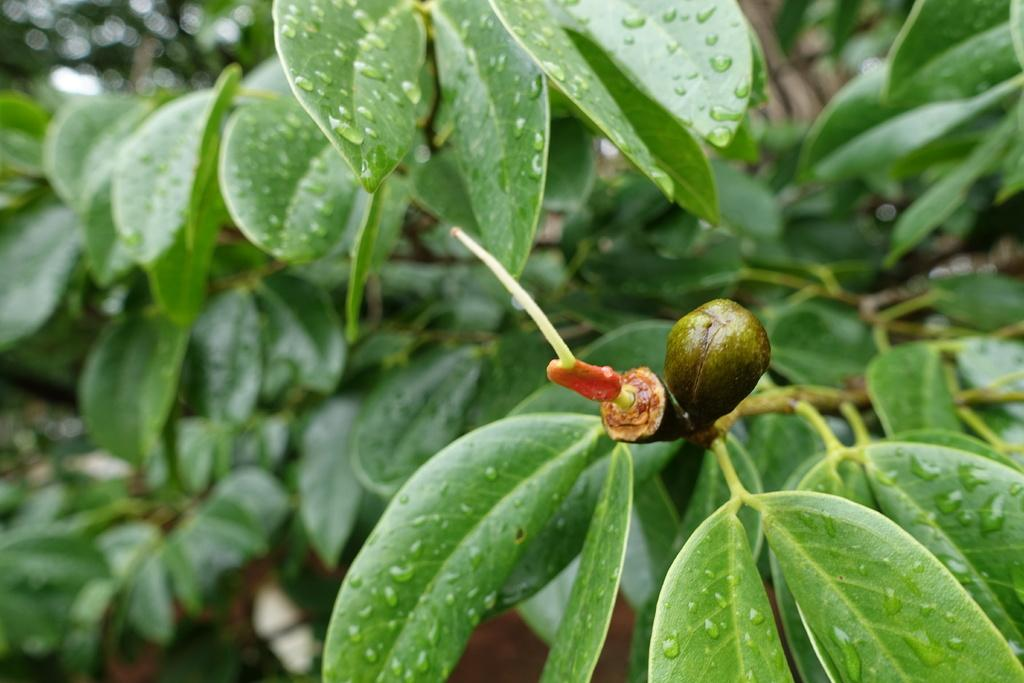What type of vegetation is present in the image? There are green leaves in the image. Can you describe the appearance of the leaves? The leaves have water droplets on them. How are the leaves attached to the plant? The leaves are on stems. What is the color of the other prominent object in the image? There is a dark green color thing in the image. What type of haircut is the plant getting in the image? There is no haircut being performed on the plant in the image; it is a photograph of a plant with leaves and stems. 